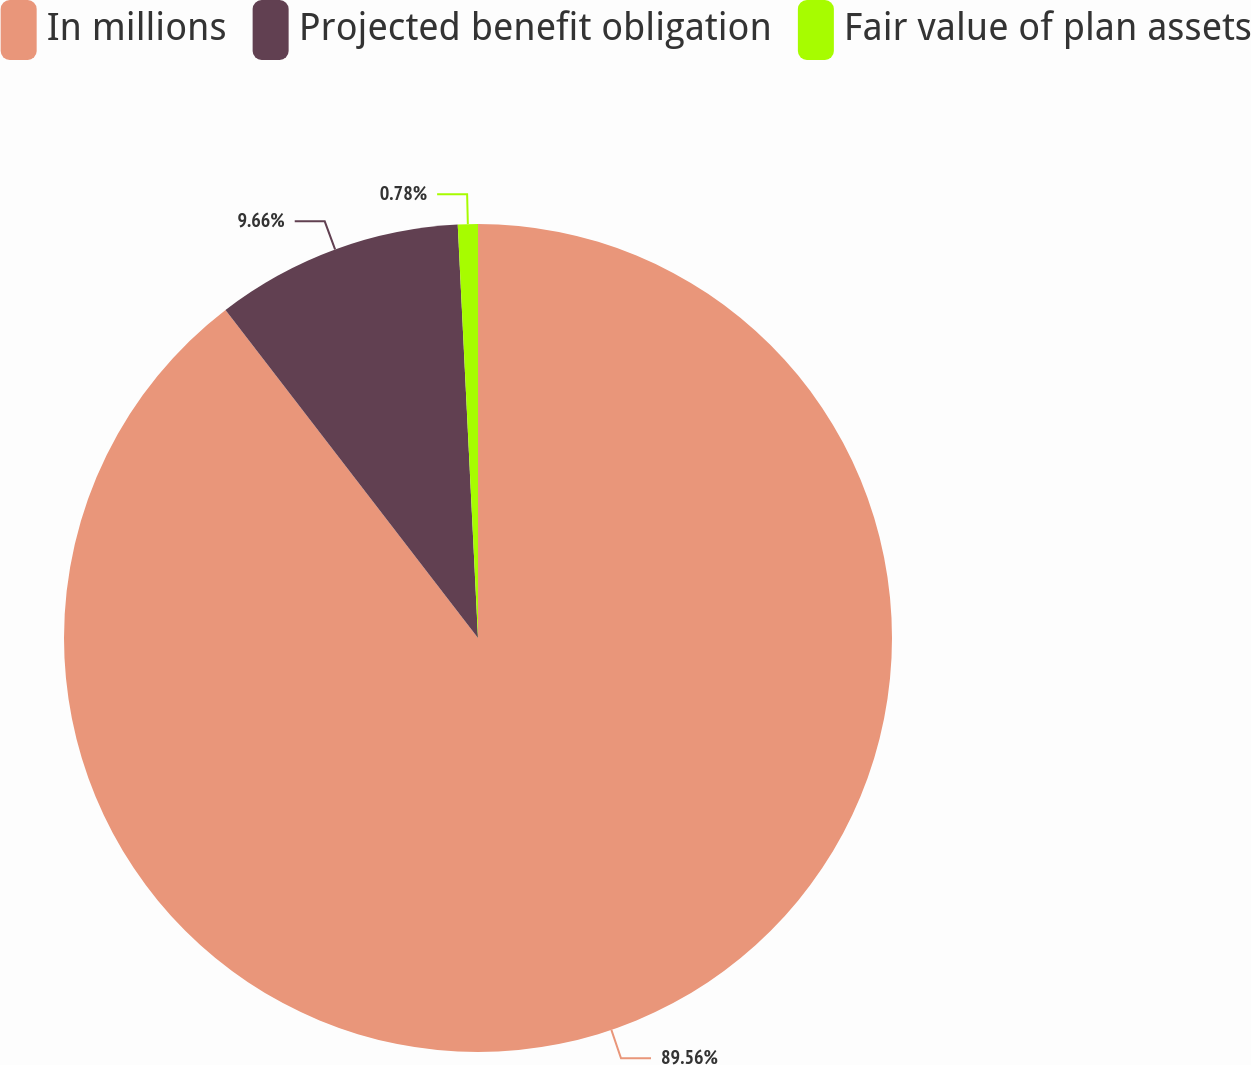Convert chart. <chart><loc_0><loc_0><loc_500><loc_500><pie_chart><fcel>In millions<fcel>Projected benefit obligation<fcel>Fair value of plan assets<nl><fcel>89.56%<fcel>9.66%<fcel>0.78%<nl></chart> 